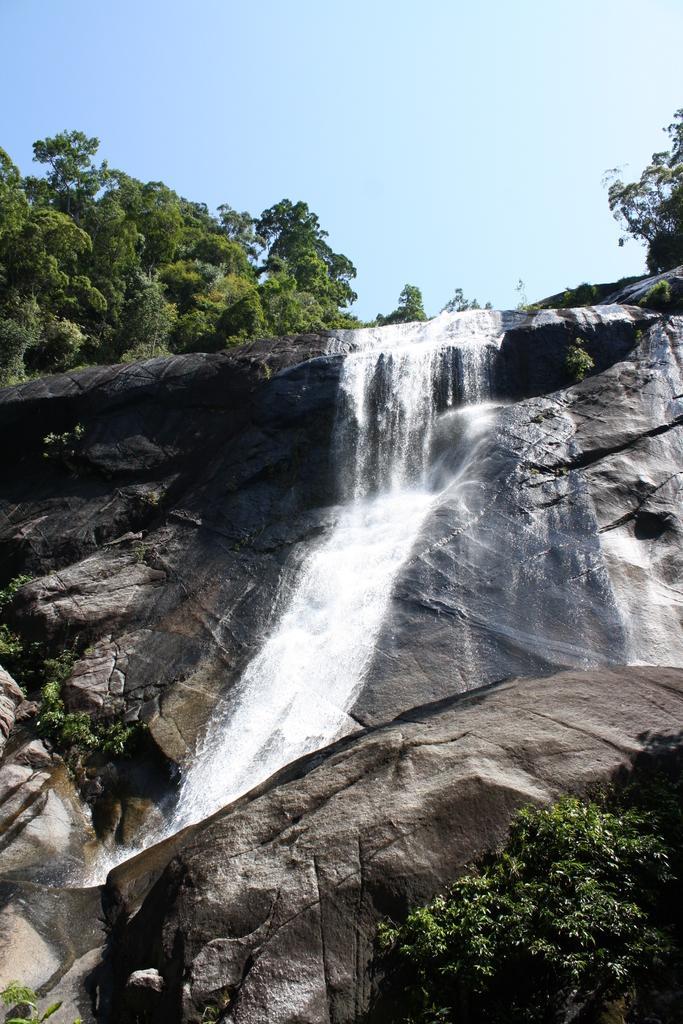How would you summarize this image in a sentence or two? In this image we can see a waterfall. There is a sky in the image. There are many trees and plants in the image. 